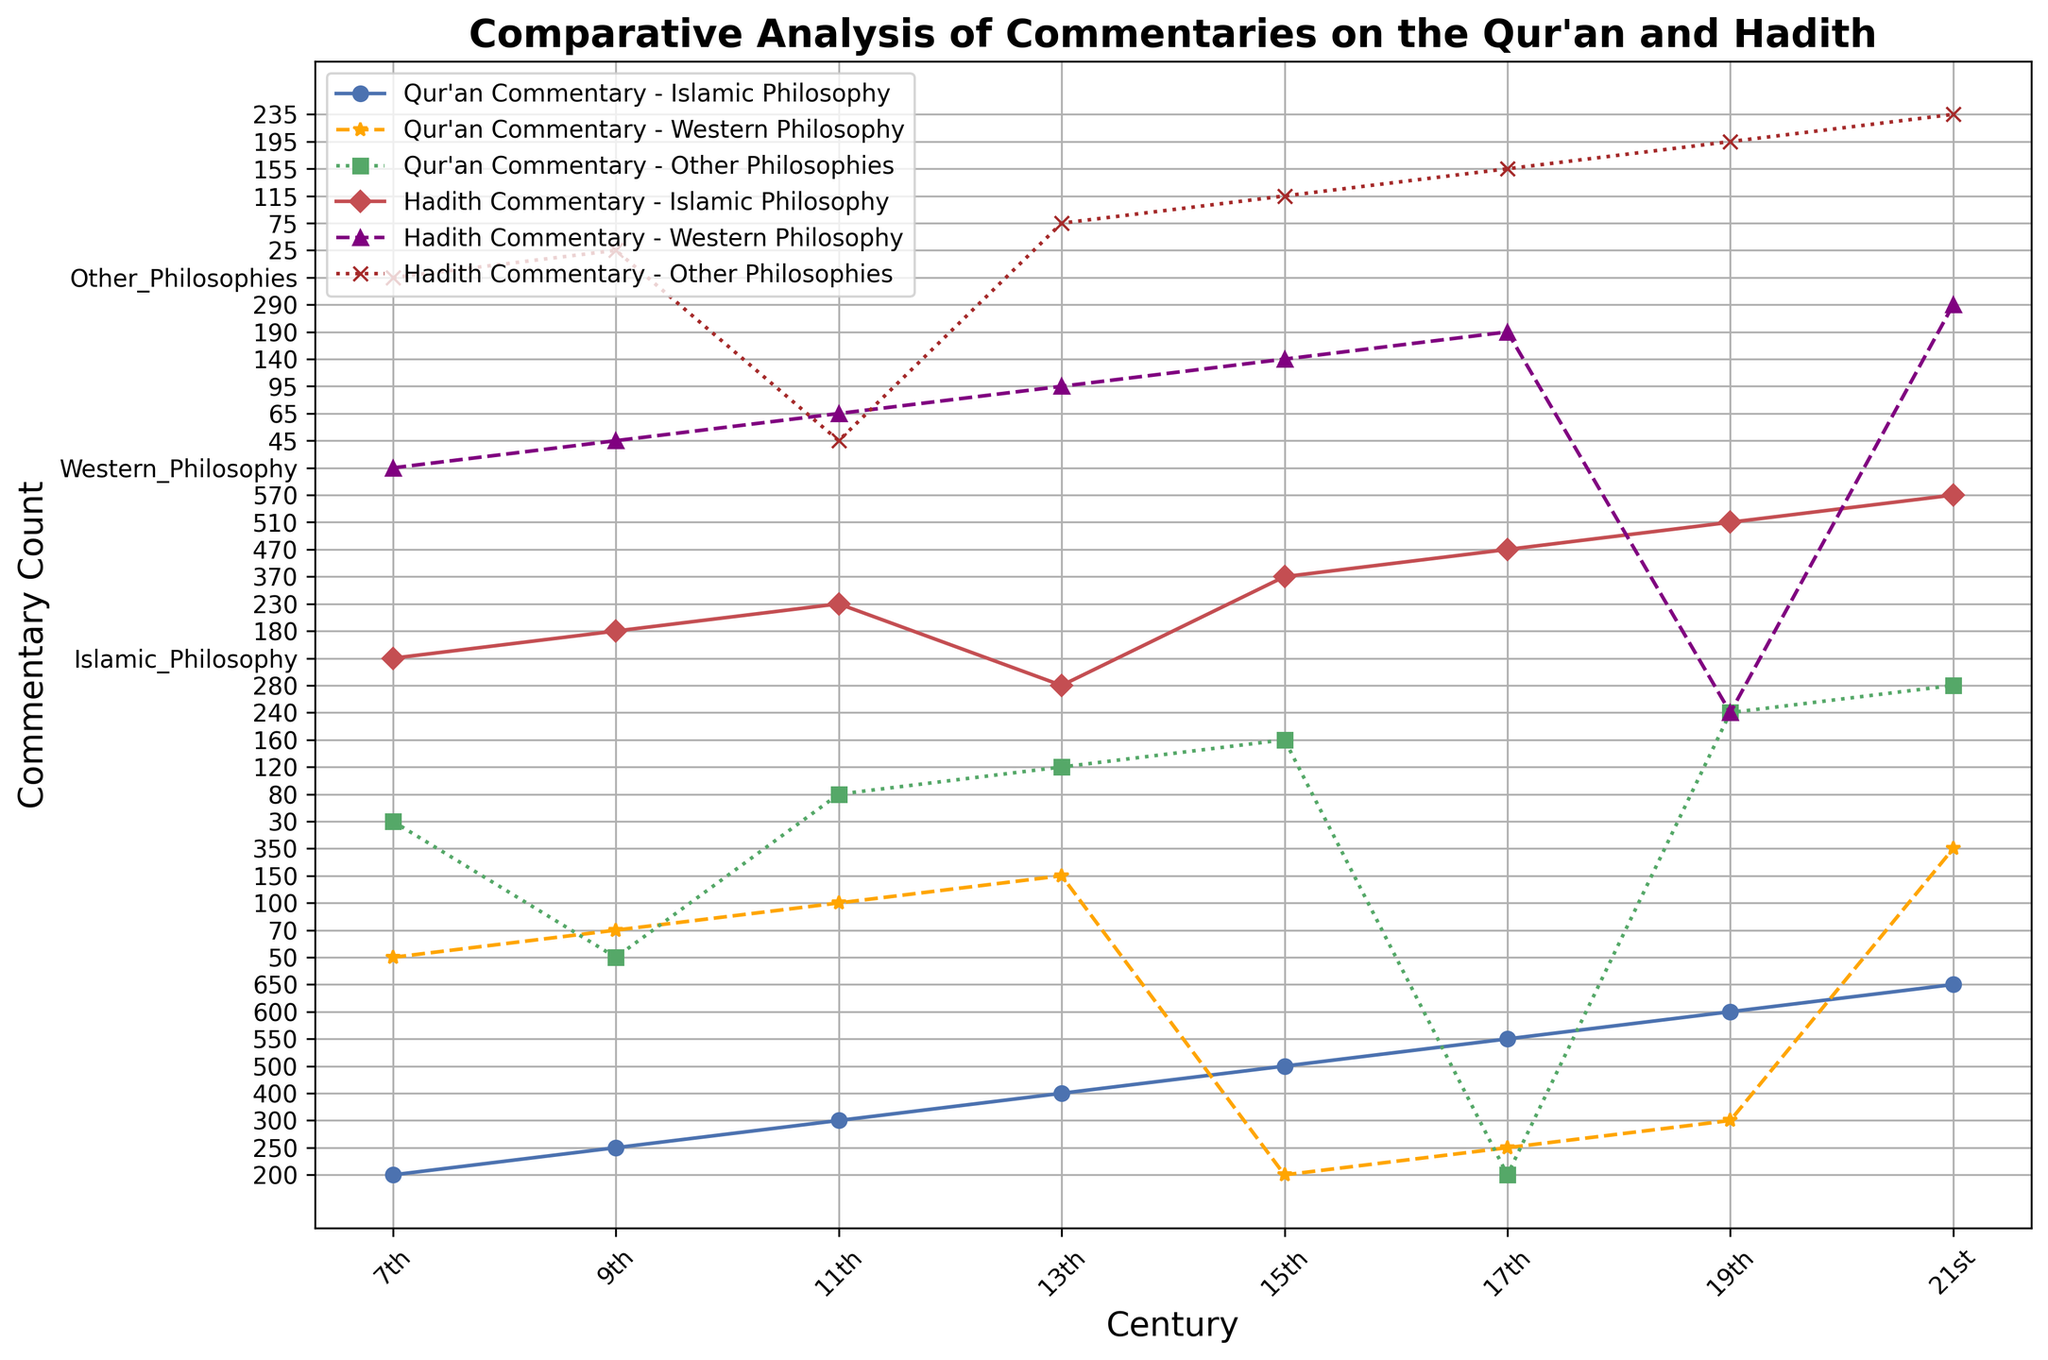What are the trends in the count of Qur'an commentary from Islamic philosophy over the centuries? To determine the trends of Qur'an commentary counts in Islamic philosophy, observe the blue line representing Qur'an commentary within Islamic philosophy. From the 7th to the 21st century, there is a consistent upward trend. Each data point on the graph shows an increment in the commentary count every few centuries.
Answer: Consistent Increase How does the count of Hadith commentary in Western philosophy in the 11th century compare to the Qur'an commentary in the same perspective and time? Observe the purple line for Hadith and the orange line for Qur'an in the 11th century. The count for Hadith commentary in Western philosophy is 95, while for the Qur'an commentary it's 100. So, the Qur'an commentary has a slightly higher count.
Answer: Qur'an commentary is slightly higher What is the average count of Qur'an commentary across Western philosophies in the 17th and 19th centuries? Add the counts of Qur'an commentary in Western philosophy for the 17th and 19th centuries (250 + 300) and divide by 2. The average count is (250 + 300) / 2 = 275.
Answer: 275 Which philosophy category shows the largest increase in count from the 7th to the 21st century for Qur'an commentaries? Observe the lines for each philosophy category for Qur'an commentaries between the 7th and 21st centuries. The largest increases are seen by comparing the starting and ending points of each line. Islamic Philosophy shows an increase from 200 to 650, Western Philosophy from 50 to 350, and Other Philosophies from 30 to 280. The largest increase is within the Islamic Philosophy.
Answer: Islamic Philosophy How does the growth in commentaries on Hadith within Other Philosophies from 11th to 19th century compare to the same period for Qur'an commentaries in the same philosophical category? For the 11th century, Hadith count is 75, and by the 19th century it is 235. Hence, the growth is 235 - 75 = 160. For the Qur'an, the counts are 80 (11th century) and 240 (19th century), making the growth 240 - 80 = 160. Both show the same growth of 160.
Answer: They have the same growth In which century did the rate of Qur'an commentary count within Islamic Philosophy see the largest increase? By calculating the differences in commentary counts for each century: 7th to 9th (200-100 = 100), 9th to 11th (300-150 = 150), 11th to 13th (400-200 = 200), 13th to 15th (500-250 = 250), 15th to 17th (550-300 = 250), 17th to 19th (600-350 = 250), and 19th to 21st (650-400 = 250), it's clear that the largest increase happened equally between the 13th to 15th, 15th to 17th, and 17th to 19th centuries.
Answer: 13th to 15th, 15th to 17th, and 17th to 19th centuries Do the Qur'an and Hadith commentaries in Islamic Philosophy follow the same trend across centuries? Both blue (Qur'an) and red (Hadith) lines show an increasing trend over the centuries when considering only Islamic Philosophy commentary. Their general direction and pattern of rise look similar, implying that they follow the same upward trend.
Answer: Yes What is the difference in count for Hadith commentary in Islamic philosophy from 9th to 15th century compared to Qur'an commentary within the same category and the same period? Hadith increases from 140 (9th) to 290 (15th), giving a difference of 290 - 140 = 150. Qur'an increases from 150 (9th) to 300 (15th), giving a difference of 300 - 150 = 150. Therefore, both show the same difference.
Answer: Same difference Between the 13th and 17th centuries, which category shows the least growth for Qur'an commentary? Calculate the difference for each category in Qur'an commentary from the 13th (Islamic: 400, Western: 150, Other: 120) to the 17th century (Islamic: 550, Western: 250, Other: 200). Islamic: 550-400 = 150, Western: 250-150 = 100, Other: 200-120 = 80. The least growth is in Other Philosophies.
Answer: Other Philosophies 